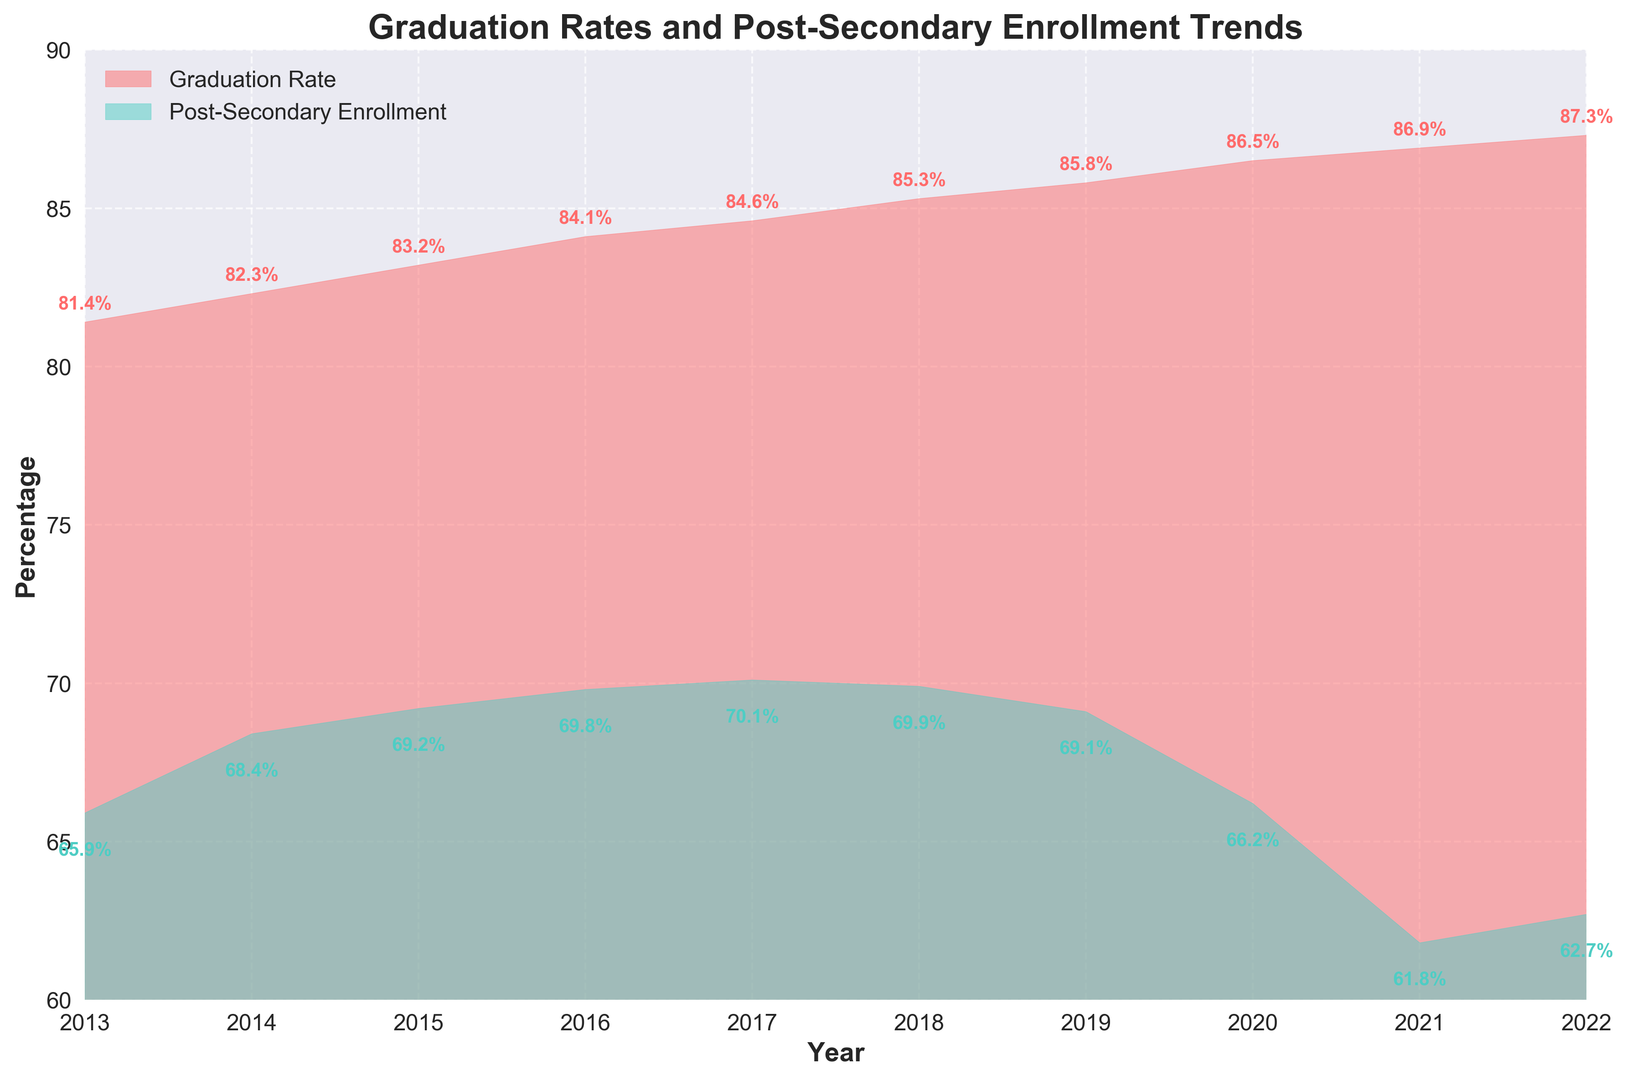What is the value of the Graduation Rate in 2020? Look at the Graduation Rate in 2020 on the x-axis and find the corresponding filled area value.
Answer: 86.5 What year has the highest Graduation Rate? Identify the year with the highest peak of the red-filled area representing Graduation Rate.
Answer: 2022 Which year shows the largest difference between Graduation Rate and Post-Secondary Enrollment? Compare the differences between the two filled areas each year, looking for the largest gap.
Answer: 2021 By how much did the Graduation Rate increase from 2013 to 2022? Subtract the Graduation Rate value of 2013 from the Graduation Rate value of 2022 (87.3 - 81.4).
Answer: 5.9 In which year did Post-Secondary Enrollment drop the most compared to the previous year? Check the year-to-year differences for Post-Secondary Enrollment and find the largest drop.
Answer: 2020 What is the average Graduation Rate over the decade (2013-2022)? Sum all the Graduation Rate values from 2013 to 2022 and divide by the number of years (81.4 + 82.3 + 83.2 + 84.1 + 84.6 + 85.3 + 85.8 + 86.5 + 86.9 + 87.3) / 10.
Answer: 84.74 Which enrollment trend is steeper, the decrease from 2017 to 2020 or the increase from 2013 to 2017? Calculate the differences over the periods (2017: 70.1 to 2020: 66.2 and 2013: 65.9 to 2017: 70.1) and compare them.
Answer: Decrease from 2017 to 2020 What is the range of Graduation Rates observed from 2013 to 2022? Subtract the minimum Graduation Rate value from the maximum value observed within the given years (87.3 - 81.4).
Answer: 5.9 Is there a year where both Graduation Rate and Post-Secondary Enrollment increased? If so, which year(s)? Compare year-to-year changes for both Graduation Rate and Post-Secondary Enrollment and identify any common increase.
Answer: 2014 How does the starting value of Post-Secondary Enrollment in 2013 compare to its ending value in 2022? Compare the Post-Secondary Enrollment values of 2013 and 2022 (65.9 vs. 62.7).
Answer: Decreased by 3.2 